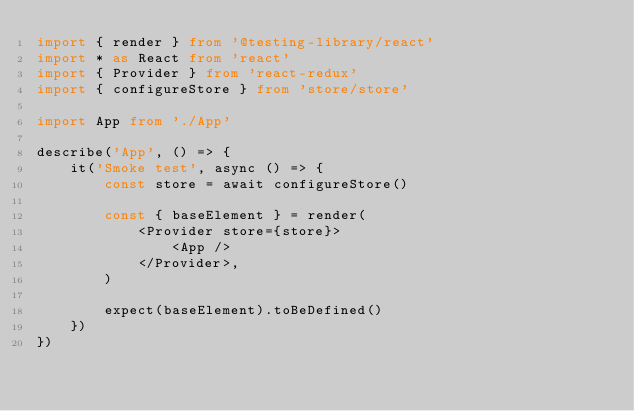<code> <loc_0><loc_0><loc_500><loc_500><_TypeScript_>import { render } from '@testing-library/react'
import * as React from 'react'
import { Provider } from 'react-redux'
import { configureStore } from 'store/store'

import App from './App'

describe('App', () => {
    it('Smoke test', async () => {
        const store = await configureStore()

        const { baseElement } = render(
            <Provider store={store}>
                <App />
            </Provider>,
        )

        expect(baseElement).toBeDefined()
    })
})
</code> 